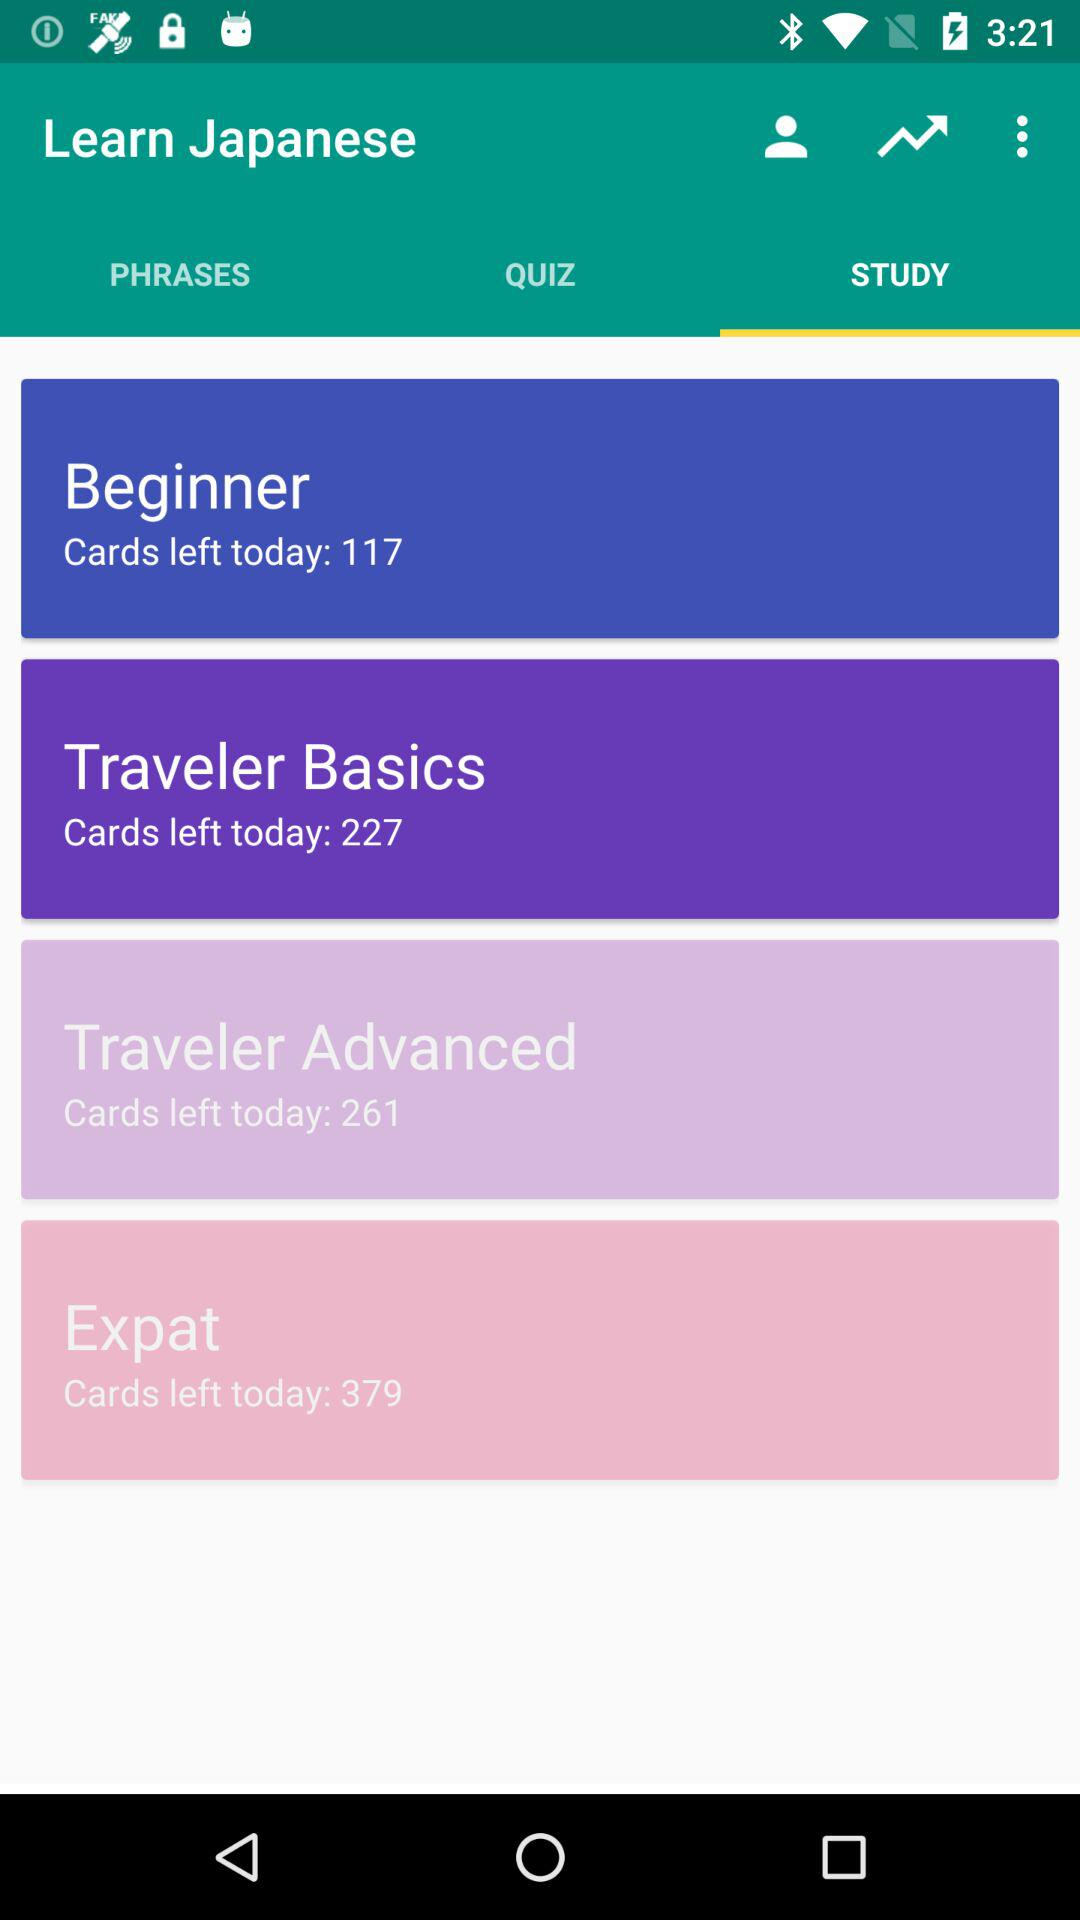How many cards are left in "Traveler Basics" for today? There are 227 cards that are left in "Traveler Basics" for today. 